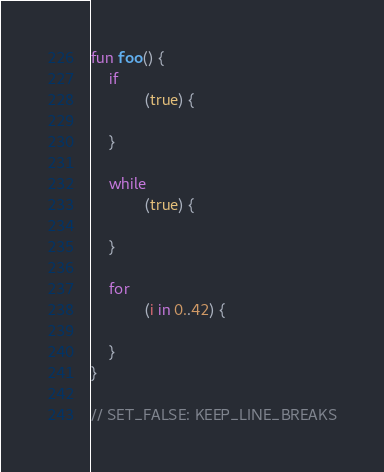<code> <loc_0><loc_0><loc_500><loc_500><_Kotlin_>fun foo() {
    if
            (true) {

    }

    while
            (true) {

    }

    for
            (i in 0..42) {

    }
}

// SET_FALSE: KEEP_LINE_BREAKS
</code> 